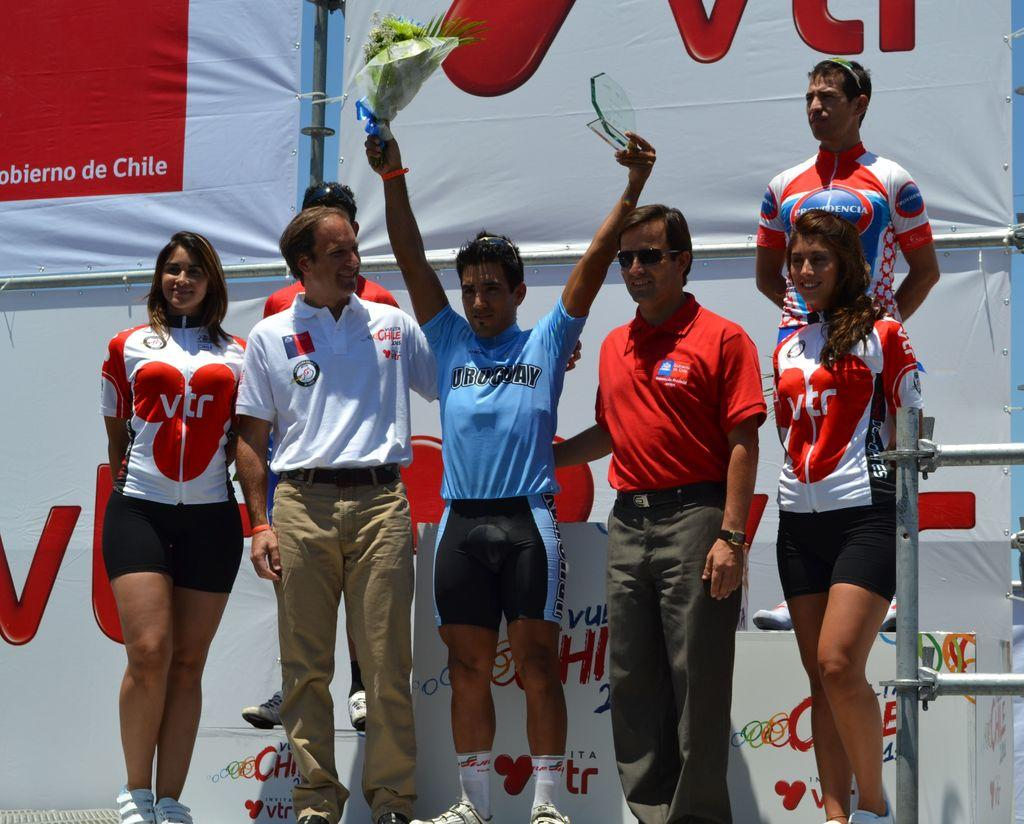What is the main subject of the image? There is a man standing in the middle of the image. What is the man wearing? The man is wearing a blue t-shirt. Are there any other people in the image? Yes, there are other people standing beside the man. What can be seen in the background of the image? There is a white color banner in the background of the image. What type of vase is placed on the table in the image? There is no table or vase present in the image; it features a man standing in the middle and other people standing beside him. What is the servant doing in the image? There is no servant present in the image. 